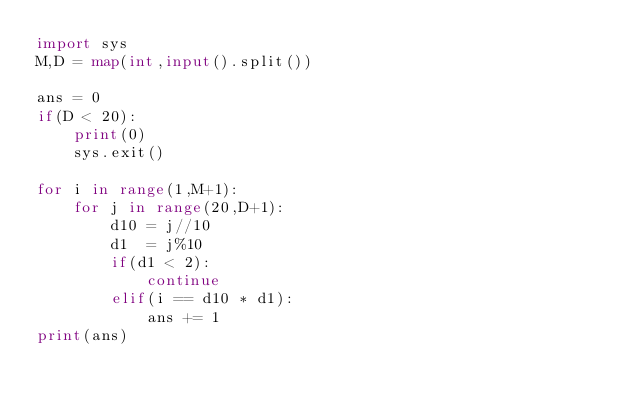<code> <loc_0><loc_0><loc_500><loc_500><_Python_>import sys
M,D = map(int,input().split())

ans = 0
if(D < 20):
    print(0)
    sys.exit()

for i in range(1,M+1):
    for j in range(20,D+1):
        d10 = j//10
        d1  = j%10
        if(d1 < 2):
            continue
        elif(i == d10 * d1):
            ans += 1
print(ans)</code> 